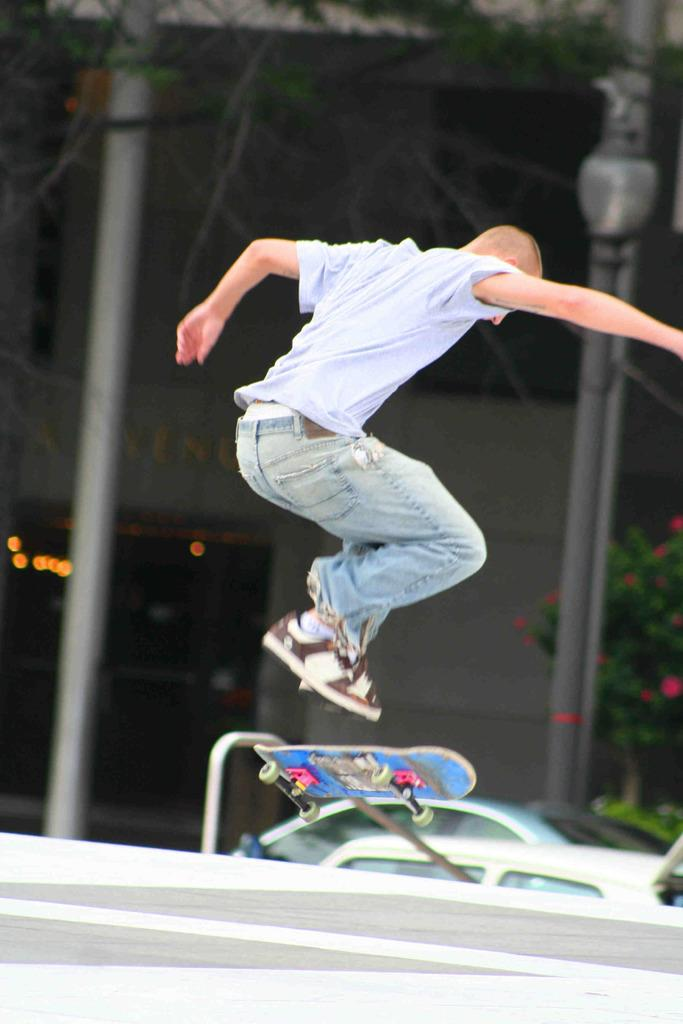What is the main subject of the image? There is a person in the image. What is the person doing in the image? The person is jumping. What is the person using to perform the action? There is a skateboard under the person. Where is the person located in the image? The person is on a road. What else can be seen in the image? There are two cars and a building in the image. What type of thread is being used to stitch the person's clothes in the image? There is no thread visible in the image, and the person's clothes are not being stitched. 